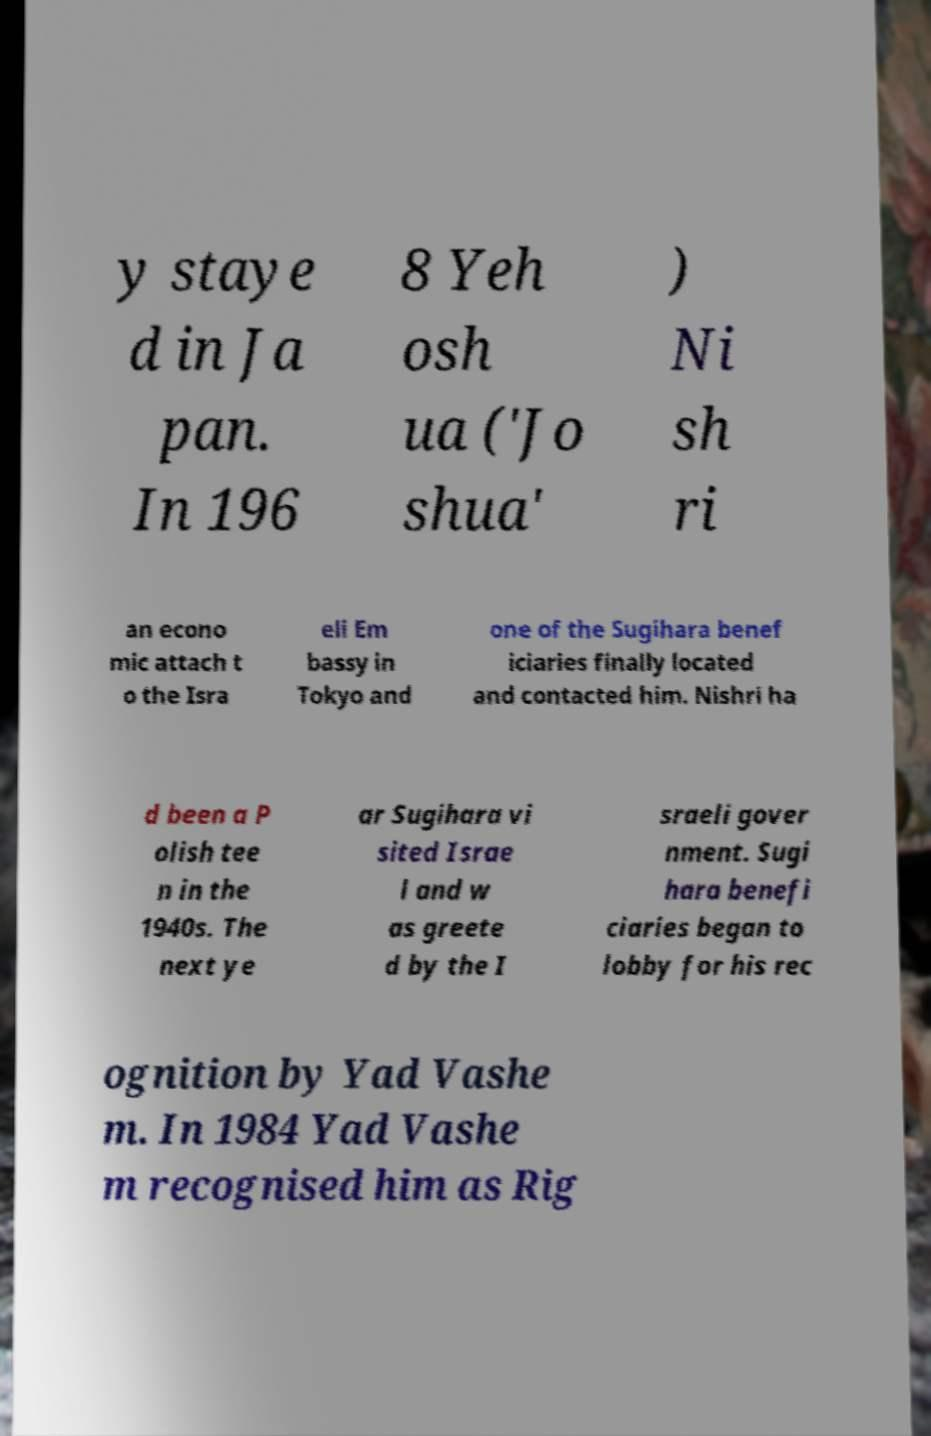Please identify and transcribe the text found in this image. y staye d in Ja pan. In 196 8 Yeh osh ua ('Jo shua' ) Ni sh ri an econo mic attach t o the Isra eli Em bassy in Tokyo and one of the Sugihara benef iciaries finally located and contacted him. Nishri ha d been a P olish tee n in the 1940s. The next ye ar Sugihara vi sited Israe l and w as greete d by the I sraeli gover nment. Sugi hara benefi ciaries began to lobby for his rec ognition by Yad Vashe m. In 1984 Yad Vashe m recognised him as Rig 